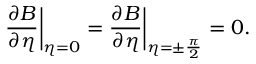<formula> <loc_0><loc_0><loc_500><loc_500>\frac { \partial B } { \partial \eta } \left | _ { \eta = 0 } = \frac { \partial B } { \partial \eta } \right | _ { \eta = \pm \frac { \pi } { 2 } } = 0 .</formula> 